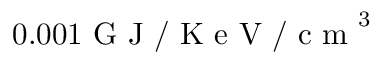Convert formula to latex. <formula><loc_0><loc_0><loc_500><loc_500>0 . 0 0 1 G J / K e V / c m ^ { 3 }</formula> 